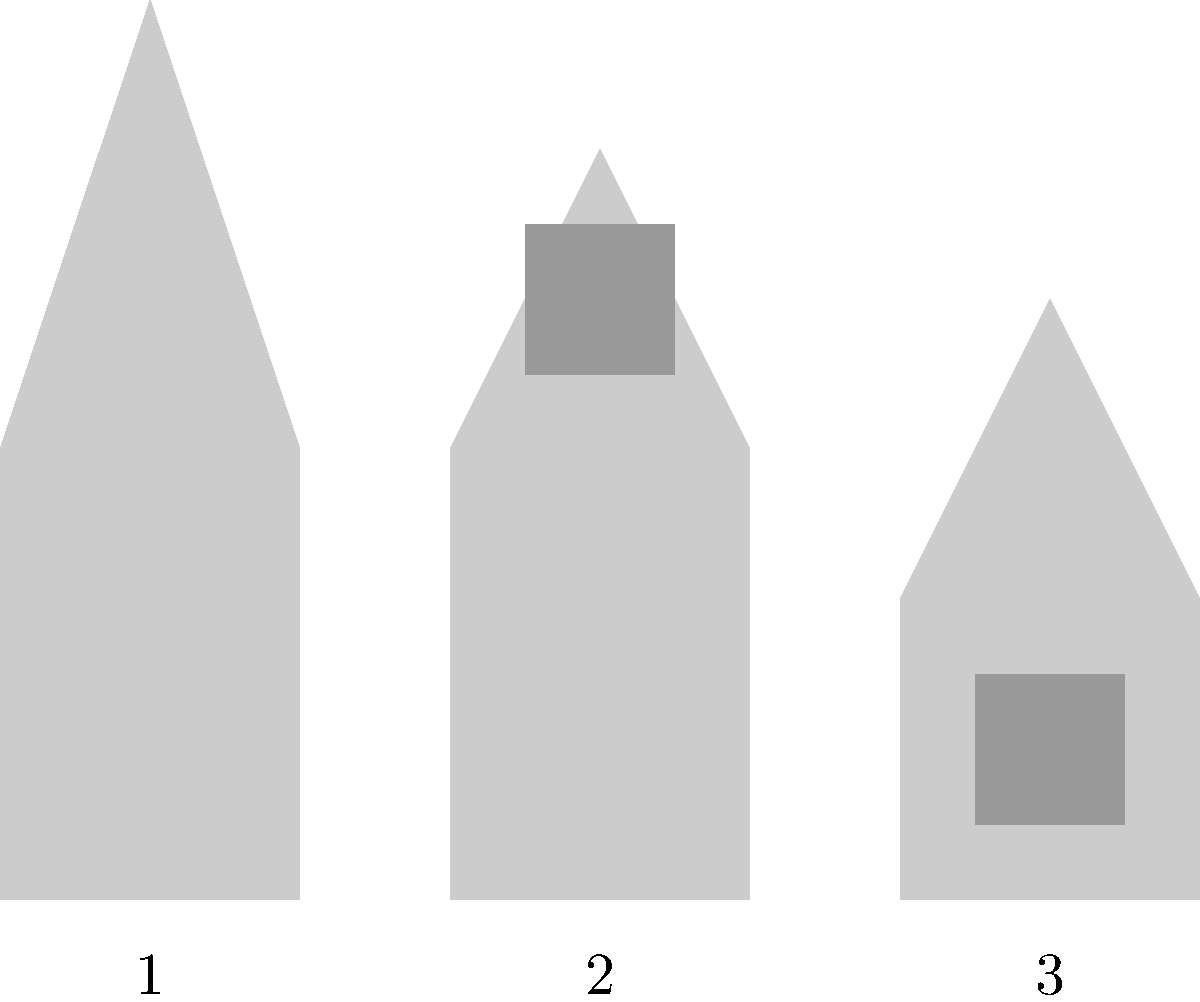Based on the silhouette images of three Cambodian Buddhist temples shown above, which architectural style is represented by Temple 2? To identify the architectural style of Temple 2, we need to analyze its distinctive features and compare them with known Cambodian Buddhist temple styles:

1. Temple 1 shows a classic pyramidal structure with a central tower, characteristic of the Angkor Wat style.

2. Temple 2 has a unique feature:
   - A square-ish structure at the top, which represents the iconic face towers.
   - This is a hallmark of the Bayon style, known for its multiple stone faces looking in different directions.

3. Temple 3 appears to be smaller and more intricate, with ornate details visible even in silhouette, typical of the Banteay Srei style.

Given these observations, Temple 2 clearly represents the Bayon style, famous for its face towers as seen in the Bayon temple at Angkor Thom.
Answer: Bayon style 